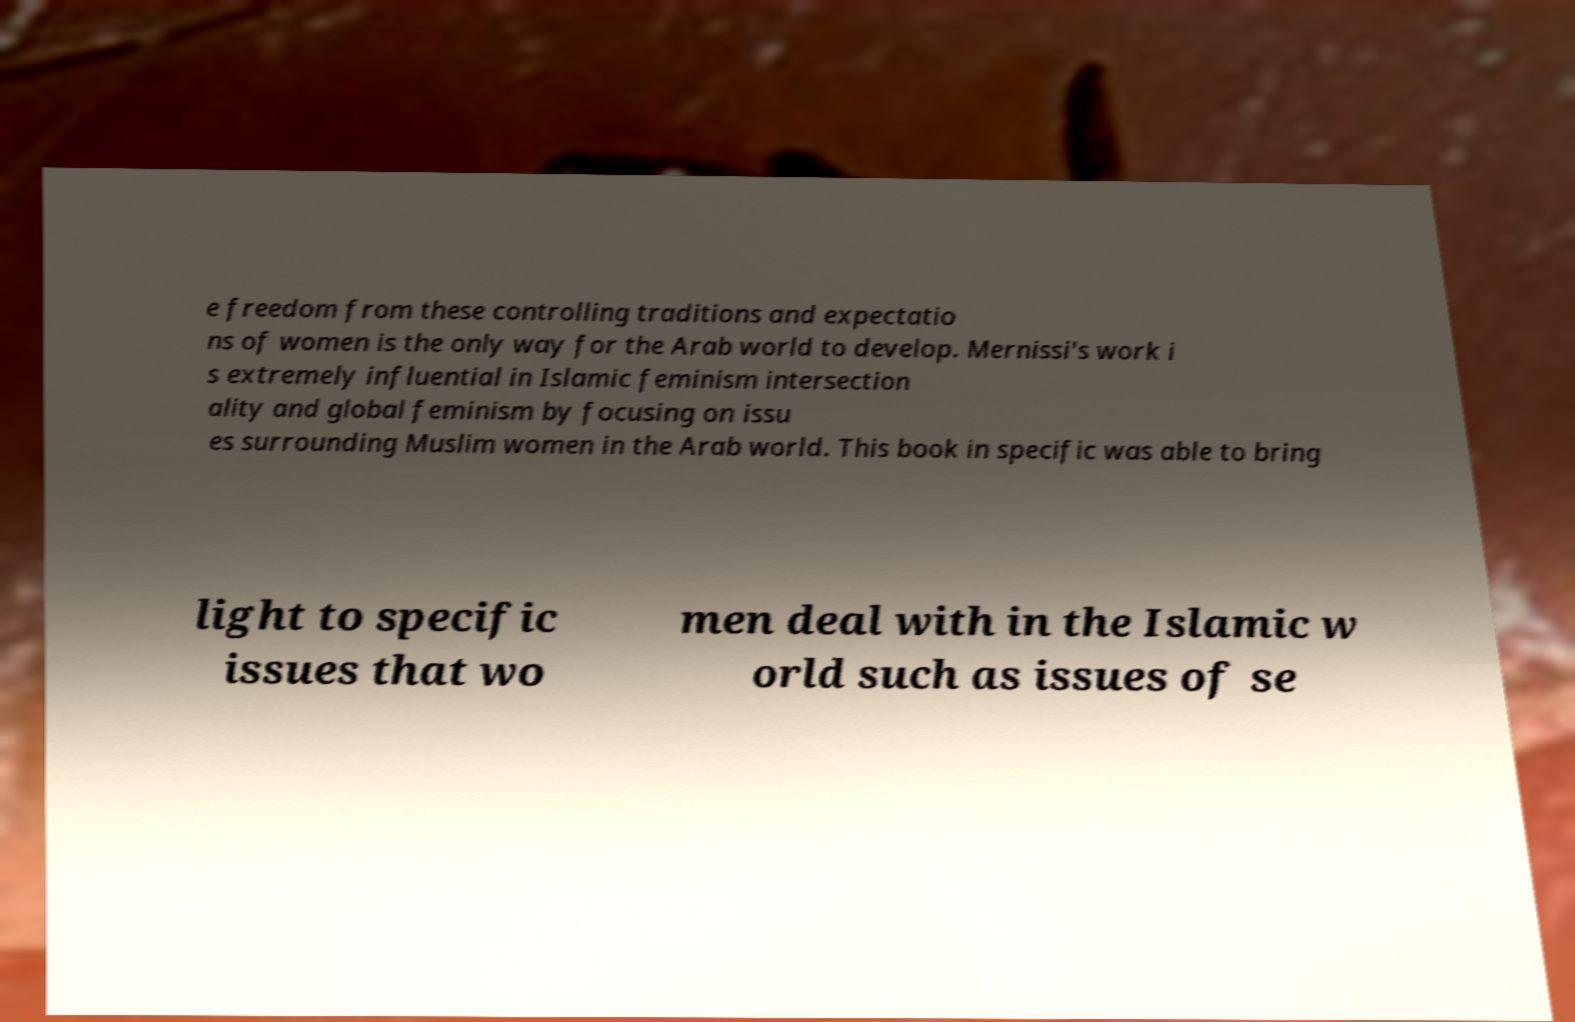Could you extract and type out the text from this image? e freedom from these controlling traditions and expectatio ns of women is the only way for the Arab world to develop. Mernissi's work i s extremely influential in Islamic feminism intersection ality and global feminism by focusing on issu es surrounding Muslim women in the Arab world. This book in specific was able to bring light to specific issues that wo men deal with in the Islamic w orld such as issues of se 